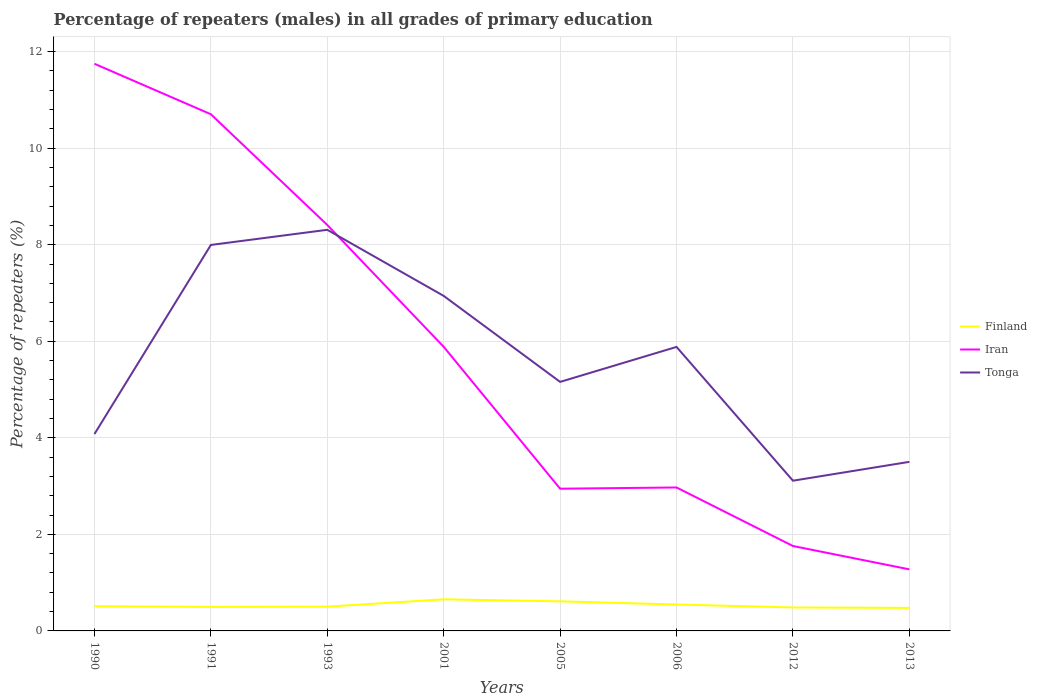Across all years, what is the maximum percentage of repeaters (males) in Finland?
Ensure brevity in your answer.  0.48. What is the total percentage of repeaters (males) in Iran in the graph?
Give a very brief answer. 4.82. What is the difference between the highest and the second highest percentage of repeaters (males) in Tonga?
Offer a terse response. 5.2. What is the difference between the highest and the lowest percentage of repeaters (males) in Iran?
Your response must be concise. 4. Is the percentage of repeaters (males) in Tonga strictly greater than the percentage of repeaters (males) in Finland over the years?
Keep it short and to the point. No. How many legend labels are there?
Provide a short and direct response. 3. What is the title of the graph?
Ensure brevity in your answer.  Percentage of repeaters (males) in all grades of primary education. Does "Middle income" appear as one of the legend labels in the graph?
Make the answer very short. No. What is the label or title of the X-axis?
Your answer should be compact. Years. What is the label or title of the Y-axis?
Your answer should be compact. Percentage of repeaters (%). What is the Percentage of repeaters (%) of Finland in 1990?
Your response must be concise. 0.51. What is the Percentage of repeaters (%) of Iran in 1990?
Provide a short and direct response. 11.75. What is the Percentage of repeaters (%) of Tonga in 1990?
Your answer should be very brief. 4.08. What is the Percentage of repeaters (%) in Finland in 1991?
Ensure brevity in your answer.  0.5. What is the Percentage of repeaters (%) in Iran in 1991?
Ensure brevity in your answer.  10.7. What is the Percentage of repeaters (%) in Tonga in 1991?
Your answer should be very brief. 7.99. What is the Percentage of repeaters (%) in Finland in 1993?
Your answer should be very brief. 0.5. What is the Percentage of repeaters (%) of Iran in 1993?
Keep it short and to the point. 8.41. What is the Percentage of repeaters (%) in Tonga in 1993?
Offer a terse response. 8.31. What is the Percentage of repeaters (%) in Finland in 2001?
Make the answer very short. 0.65. What is the Percentage of repeaters (%) of Iran in 2001?
Your response must be concise. 5.88. What is the Percentage of repeaters (%) of Tonga in 2001?
Your answer should be compact. 6.94. What is the Percentage of repeaters (%) of Finland in 2005?
Your answer should be very brief. 0.61. What is the Percentage of repeaters (%) of Iran in 2005?
Your answer should be very brief. 2.95. What is the Percentage of repeaters (%) in Tonga in 2005?
Ensure brevity in your answer.  5.16. What is the Percentage of repeaters (%) in Finland in 2006?
Keep it short and to the point. 0.55. What is the Percentage of repeaters (%) in Iran in 2006?
Ensure brevity in your answer.  2.97. What is the Percentage of repeaters (%) of Tonga in 2006?
Make the answer very short. 5.88. What is the Percentage of repeaters (%) of Finland in 2012?
Offer a terse response. 0.49. What is the Percentage of repeaters (%) of Iran in 2012?
Give a very brief answer. 1.76. What is the Percentage of repeaters (%) of Tonga in 2012?
Offer a very short reply. 3.11. What is the Percentage of repeaters (%) of Finland in 2013?
Provide a short and direct response. 0.48. What is the Percentage of repeaters (%) of Iran in 2013?
Your answer should be very brief. 1.28. What is the Percentage of repeaters (%) in Tonga in 2013?
Make the answer very short. 3.5. Across all years, what is the maximum Percentage of repeaters (%) of Finland?
Your answer should be compact. 0.65. Across all years, what is the maximum Percentage of repeaters (%) in Iran?
Offer a terse response. 11.75. Across all years, what is the maximum Percentage of repeaters (%) of Tonga?
Offer a very short reply. 8.31. Across all years, what is the minimum Percentage of repeaters (%) of Finland?
Make the answer very short. 0.48. Across all years, what is the minimum Percentage of repeaters (%) in Iran?
Your answer should be compact. 1.28. Across all years, what is the minimum Percentage of repeaters (%) of Tonga?
Your answer should be very brief. 3.11. What is the total Percentage of repeaters (%) of Finland in the graph?
Your answer should be compact. 4.29. What is the total Percentage of repeaters (%) in Iran in the graph?
Keep it short and to the point. 45.69. What is the total Percentage of repeaters (%) in Tonga in the graph?
Offer a very short reply. 44.98. What is the difference between the Percentage of repeaters (%) of Finland in 1990 and that in 1991?
Your answer should be very brief. 0.01. What is the difference between the Percentage of repeaters (%) in Iran in 1990 and that in 1991?
Your response must be concise. 1.05. What is the difference between the Percentage of repeaters (%) of Tonga in 1990 and that in 1991?
Give a very brief answer. -3.92. What is the difference between the Percentage of repeaters (%) in Finland in 1990 and that in 1993?
Make the answer very short. 0.01. What is the difference between the Percentage of repeaters (%) of Iran in 1990 and that in 1993?
Give a very brief answer. 3.34. What is the difference between the Percentage of repeaters (%) in Tonga in 1990 and that in 1993?
Your response must be concise. -4.23. What is the difference between the Percentage of repeaters (%) in Finland in 1990 and that in 2001?
Give a very brief answer. -0.14. What is the difference between the Percentage of repeaters (%) in Iran in 1990 and that in 2001?
Give a very brief answer. 5.86. What is the difference between the Percentage of repeaters (%) of Tonga in 1990 and that in 2001?
Provide a succinct answer. -2.86. What is the difference between the Percentage of repeaters (%) of Finland in 1990 and that in 2005?
Offer a very short reply. -0.1. What is the difference between the Percentage of repeaters (%) in Iran in 1990 and that in 2005?
Your answer should be very brief. 8.8. What is the difference between the Percentage of repeaters (%) of Tonga in 1990 and that in 2005?
Your answer should be very brief. -1.08. What is the difference between the Percentage of repeaters (%) of Finland in 1990 and that in 2006?
Your response must be concise. -0.04. What is the difference between the Percentage of repeaters (%) of Iran in 1990 and that in 2006?
Provide a short and direct response. 8.78. What is the difference between the Percentage of repeaters (%) in Tonga in 1990 and that in 2006?
Make the answer very short. -1.8. What is the difference between the Percentage of repeaters (%) in Finland in 1990 and that in 2012?
Keep it short and to the point. 0.03. What is the difference between the Percentage of repeaters (%) in Iran in 1990 and that in 2012?
Offer a very short reply. 9.99. What is the difference between the Percentage of repeaters (%) in Tonga in 1990 and that in 2012?
Offer a terse response. 0.97. What is the difference between the Percentage of repeaters (%) of Finland in 1990 and that in 2013?
Provide a succinct answer. 0.03. What is the difference between the Percentage of repeaters (%) in Iran in 1990 and that in 2013?
Offer a terse response. 10.47. What is the difference between the Percentage of repeaters (%) of Tonga in 1990 and that in 2013?
Give a very brief answer. 0.58. What is the difference between the Percentage of repeaters (%) of Finland in 1991 and that in 1993?
Your answer should be very brief. -0.01. What is the difference between the Percentage of repeaters (%) of Iran in 1991 and that in 1993?
Your response must be concise. 2.29. What is the difference between the Percentage of repeaters (%) in Tonga in 1991 and that in 1993?
Your answer should be compact. -0.31. What is the difference between the Percentage of repeaters (%) of Finland in 1991 and that in 2001?
Make the answer very short. -0.16. What is the difference between the Percentage of repeaters (%) in Iran in 1991 and that in 2001?
Provide a short and direct response. 4.82. What is the difference between the Percentage of repeaters (%) in Tonga in 1991 and that in 2001?
Offer a terse response. 1.06. What is the difference between the Percentage of repeaters (%) in Finland in 1991 and that in 2005?
Provide a succinct answer. -0.12. What is the difference between the Percentage of repeaters (%) in Iran in 1991 and that in 2005?
Give a very brief answer. 7.76. What is the difference between the Percentage of repeaters (%) in Tonga in 1991 and that in 2005?
Your answer should be very brief. 2.84. What is the difference between the Percentage of repeaters (%) in Finland in 1991 and that in 2006?
Make the answer very short. -0.05. What is the difference between the Percentage of repeaters (%) in Iran in 1991 and that in 2006?
Ensure brevity in your answer.  7.73. What is the difference between the Percentage of repeaters (%) of Tonga in 1991 and that in 2006?
Keep it short and to the point. 2.11. What is the difference between the Percentage of repeaters (%) of Finland in 1991 and that in 2012?
Your answer should be compact. 0.01. What is the difference between the Percentage of repeaters (%) of Iran in 1991 and that in 2012?
Your answer should be compact. 8.94. What is the difference between the Percentage of repeaters (%) in Tonga in 1991 and that in 2012?
Make the answer very short. 4.88. What is the difference between the Percentage of repeaters (%) of Finland in 1991 and that in 2013?
Provide a short and direct response. 0.02. What is the difference between the Percentage of repeaters (%) in Iran in 1991 and that in 2013?
Give a very brief answer. 9.43. What is the difference between the Percentage of repeaters (%) in Tonga in 1991 and that in 2013?
Make the answer very short. 4.49. What is the difference between the Percentage of repeaters (%) in Finland in 1993 and that in 2001?
Your answer should be very brief. -0.15. What is the difference between the Percentage of repeaters (%) of Iran in 1993 and that in 2001?
Make the answer very short. 2.52. What is the difference between the Percentage of repeaters (%) in Tonga in 1993 and that in 2001?
Offer a very short reply. 1.37. What is the difference between the Percentage of repeaters (%) of Finland in 1993 and that in 2005?
Provide a succinct answer. -0.11. What is the difference between the Percentage of repeaters (%) in Iran in 1993 and that in 2005?
Your answer should be compact. 5.46. What is the difference between the Percentage of repeaters (%) of Tonga in 1993 and that in 2005?
Your answer should be compact. 3.15. What is the difference between the Percentage of repeaters (%) of Finland in 1993 and that in 2006?
Give a very brief answer. -0.04. What is the difference between the Percentage of repeaters (%) in Iran in 1993 and that in 2006?
Keep it short and to the point. 5.44. What is the difference between the Percentage of repeaters (%) in Tonga in 1993 and that in 2006?
Keep it short and to the point. 2.43. What is the difference between the Percentage of repeaters (%) of Finland in 1993 and that in 2012?
Your response must be concise. 0.02. What is the difference between the Percentage of repeaters (%) of Iran in 1993 and that in 2012?
Offer a terse response. 6.65. What is the difference between the Percentage of repeaters (%) of Tonga in 1993 and that in 2012?
Ensure brevity in your answer.  5.2. What is the difference between the Percentage of repeaters (%) of Finland in 1993 and that in 2013?
Your answer should be compact. 0.03. What is the difference between the Percentage of repeaters (%) in Iran in 1993 and that in 2013?
Make the answer very short. 7.13. What is the difference between the Percentage of repeaters (%) of Tonga in 1993 and that in 2013?
Offer a terse response. 4.81. What is the difference between the Percentage of repeaters (%) in Finland in 2001 and that in 2005?
Make the answer very short. 0.04. What is the difference between the Percentage of repeaters (%) of Iran in 2001 and that in 2005?
Give a very brief answer. 2.94. What is the difference between the Percentage of repeaters (%) of Tonga in 2001 and that in 2005?
Your answer should be compact. 1.78. What is the difference between the Percentage of repeaters (%) of Finland in 2001 and that in 2006?
Make the answer very short. 0.11. What is the difference between the Percentage of repeaters (%) of Iran in 2001 and that in 2006?
Offer a very short reply. 2.91. What is the difference between the Percentage of repeaters (%) of Tonga in 2001 and that in 2006?
Your response must be concise. 1.06. What is the difference between the Percentage of repeaters (%) in Finland in 2001 and that in 2012?
Offer a terse response. 0.17. What is the difference between the Percentage of repeaters (%) in Iran in 2001 and that in 2012?
Keep it short and to the point. 4.13. What is the difference between the Percentage of repeaters (%) in Tonga in 2001 and that in 2012?
Ensure brevity in your answer.  3.83. What is the difference between the Percentage of repeaters (%) in Finland in 2001 and that in 2013?
Your answer should be compact. 0.18. What is the difference between the Percentage of repeaters (%) in Iran in 2001 and that in 2013?
Your answer should be very brief. 4.61. What is the difference between the Percentage of repeaters (%) in Tonga in 2001 and that in 2013?
Make the answer very short. 3.44. What is the difference between the Percentage of repeaters (%) of Finland in 2005 and that in 2006?
Provide a succinct answer. 0.07. What is the difference between the Percentage of repeaters (%) in Iran in 2005 and that in 2006?
Provide a succinct answer. -0.03. What is the difference between the Percentage of repeaters (%) in Tonga in 2005 and that in 2006?
Keep it short and to the point. -0.72. What is the difference between the Percentage of repeaters (%) in Finland in 2005 and that in 2012?
Make the answer very short. 0.13. What is the difference between the Percentage of repeaters (%) of Iran in 2005 and that in 2012?
Ensure brevity in your answer.  1.19. What is the difference between the Percentage of repeaters (%) in Tonga in 2005 and that in 2012?
Your answer should be very brief. 2.05. What is the difference between the Percentage of repeaters (%) in Finland in 2005 and that in 2013?
Your response must be concise. 0.14. What is the difference between the Percentage of repeaters (%) of Iran in 2005 and that in 2013?
Your answer should be compact. 1.67. What is the difference between the Percentage of repeaters (%) of Tonga in 2005 and that in 2013?
Provide a succinct answer. 1.66. What is the difference between the Percentage of repeaters (%) in Finland in 2006 and that in 2012?
Provide a short and direct response. 0.06. What is the difference between the Percentage of repeaters (%) in Iran in 2006 and that in 2012?
Keep it short and to the point. 1.21. What is the difference between the Percentage of repeaters (%) in Tonga in 2006 and that in 2012?
Offer a terse response. 2.77. What is the difference between the Percentage of repeaters (%) of Finland in 2006 and that in 2013?
Offer a very short reply. 0.07. What is the difference between the Percentage of repeaters (%) in Iran in 2006 and that in 2013?
Offer a very short reply. 1.7. What is the difference between the Percentage of repeaters (%) in Tonga in 2006 and that in 2013?
Keep it short and to the point. 2.38. What is the difference between the Percentage of repeaters (%) of Finland in 2012 and that in 2013?
Offer a terse response. 0.01. What is the difference between the Percentage of repeaters (%) of Iran in 2012 and that in 2013?
Give a very brief answer. 0.48. What is the difference between the Percentage of repeaters (%) of Tonga in 2012 and that in 2013?
Your answer should be very brief. -0.39. What is the difference between the Percentage of repeaters (%) in Finland in 1990 and the Percentage of repeaters (%) in Iran in 1991?
Offer a very short reply. -10.19. What is the difference between the Percentage of repeaters (%) in Finland in 1990 and the Percentage of repeaters (%) in Tonga in 1991?
Make the answer very short. -7.48. What is the difference between the Percentage of repeaters (%) in Iran in 1990 and the Percentage of repeaters (%) in Tonga in 1991?
Make the answer very short. 3.75. What is the difference between the Percentage of repeaters (%) of Finland in 1990 and the Percentage of repeaters (%) of Iran in 1993?
Offer a terse response. -7.9. What is the difference between the Percentage of repeaters (%) of Finland in 1990 and the Percentage of repeaters (%) of Tonga in 1993?
Offer a very short reply. -7.8. What is the difference between the Percentage of repeaters (%) of Iran in 1990 and the Percentage of repeaters (%) of Tonga in 1993?
Provide a succinct answer. 3.44. What is the difference between the Percentage of repeaters (%) in Finland in 1990 and the Percentage of repeaters (%) in Iran in 2001?
Offer a very short reply. -5.37. What is the difference between the Percentage of repeaters (%) of Finland in 1990 and the Percentage of repeaters (%) of Tonga in 2001?
Provide a short and direct response. -6.43. What is the difference between the Percentage of repeaters (%) in Iran in 1990 and the Percentage of repeaters (%) in Tonga in 2001?
Offer a terse response. 4.81. What is the difference between the Percentage of repeaters (%) of Finland in 1990 and the Percentage of repeaters (%) of Iran in 2005?
Offer a very short reply. -2.43. What is the difference between the Percentage of repeaters (%) of Finland in 1990 and the Percentage of repeaters (%) of Tonga in 2005?
Ensure brevity in your answer.  -4.65. What is the difference between the Percentage of repeaters (%) of Iran in 1990 and the Percentage of repeaters (%) of Tonga in 2005?
Offer a very short reply. 6.59. What is the difference between the Percentage of repeaters (%) of Finland in 1990 and the Percentage of repeaters (%) of Iran in 2006?
Your answer should be very brief. -2.46. What is the difference between the Percentage of repeaters (%) in Finland in 1990 and the Percentage of repeaters (%) in Tonga in 2006?
Your response must be concise. -5.37. What is the difference between the Percentage of repeaters (%) of Iran in 1990 and the Percentage of repeaters (%) of Tonga in 2006?
Your answer should be compact. 5.86. What is the difference between the Percentage of repeaters (%) of Finland in 1990 and the Percentage of repeaters (%) of Iran in 2012?
Provide a succinct answer. -1.25. What is the difference between the Percentage of repeaters (%) of Finland in 1990 and the Percentage of repeaters (%) of Tonga in 2012?
Make the answer very short. -2.6. What is the difference between the Percentage of repeaters (%) in Iran in 1990 and the Percentage of repeaters (%) in Tonga in 2012?
Your answer should be compact. 8.64. What is the difference between the Percentage of repeaters (%) of Finland in 1990 and the Percentage of repeaters (%) of Iran in 2013?
Keep it short and to the point. -0.76. What is the difference between the Percentage of repeaters (%) in Finland in 1990 and the Percentage of repeaters (%) in Tonga in 2013?
Give a very brief answer. -2.99. What is the difference between the Percentage of repeaters (%) of Iran in 1990 and the Percentage of repeaters (%) of Tonga in 2013?
Provide a succinct answer. 8.25. What is the difference between the Percentage of repeaters (%) of Finland in 1991 and the Percentage of repeaters (%) of Iran in 1993?
Your answer should be very brief. -7.91. What is the difference between the Percentage of repeaters (%) of Finland in 1991 and the Percentage of repeaters (%) of Tonga in 1993?
Provide a succinct answer. -7.81. What is the difference between the Percentage of repeaters (%) of Iran in 1991 and the Percentage of repeaters (%) of Tonga in 1993?
Give a very brief answer. 2.39. What is the difference between the Percentage of repeaters (%) of Finland in 1991 and the Percentage of repeaters (%) of Iran in 2001?
Offer a terse response. -5.39. What is the difference between the Percentage of repeaters (%) of Finland in 1991 and the Percentage of repeaters (%) of Tonga in 2001?
Provide a succinct answer. -6.44. What is the difference between the Percentage of repeaters (%) in Iran in 1991 and the Percentage of repeaters (%) in Tonga in 2001?
Offer a very short reply. 3.76. What is the difference between the Percentage of repeaters (%) of Finland in 1991 and the Percentage of repeaters (%) of Iran in 2005?
Your answer should be compact. -2.45. What is the difference between the Percentage of repeaters (%) of Finland in 1991 and the Percentage of repeaters (%) of Tonga in 2005?
Provide a short and direct response. -4.66. What is the difference between the Percentage of repeaters (%) of Iran in 1991 and the Percentage of repeaters (%) of Tonga in 2005?
Give a very brief answer. 5.54. What is the difference between the Percentage of repeaters (%) in Finland in 1991 and the Percentage of repeaters (%) in Iran in 2006?
Your answer should be compact. -2.47. What is the difference between the Percentage of repeaters (%) of Finland in 1991 and the Percentage of repeaters (%) of Tonga in 2006?
Keep it short and to the point. -5.39. What is the difference between the Percentage of repeaters (%) in Iran in 1991 and the Percentage of repeaters (%) in Tonga in 2006?
Provide a succinct answer. 4.82. What is the difference between the Percentage of repeaters (%) in Finland in 1991 and the Percentage of repeaters (%) in Iran in 2012?
Your answer should be compact. -1.26. What is the difference between the Percentage of repeaters (%) of Finland in 1991 and the Percentage of repeaters (%) of Tonga in 2012?
Make the answer very short. -2.61. What is the difference between the Percentage of repeaters (%) in Iran in 1991 and the Percentage of repeaters (%) in Tonga in 2012?
Provide a short and direct response. 7.59. What is the difference between the Percentage of repeaters (%) in Finland in 1991 and the Percentage of repeaters (%) in Iran in 2013?
Ensure brevity in your answer.  -0.78. What is the difference between the Percentage of repeaters (%) in Finland in 1991 and the Percentage of repeaters (%) in Tonga in 2013?
Your answer should be very brief. -3. What is the difference between the Percentage of repeaters (%) in Iran in 1991 and the Percentage of repeaters (%) in Tonga in 2013?
Your response must be concise. 7.2. What is the difference between the Percentage of repeaters (%) of Finland in 1993 and the Percentage of repeaters (%) of Iran in 2001?
Make the answer very short. -5.38. What is the difference between the Percentage of repeaters (%) of Finland in 1993 and the Percentage of repeaters (%) of Tonga in 2001?
Your answer should be compact. -6.44. What is the difference between the Percentage of repeaters (%) in Iran in 1993 and the Percentage of repeaters (%) in Tonga in 2001?
Your response must be concise. 1.47. What is the difference between the Percentage of repeaters (%) in Finland in 1993 and the Percentage of repeaters (%) in Iran in 2005?
Your response must be concise. -2.44. What is the difference between the Percentage of repeaters (%) of Finland in 1993 and the Percentage of repeaters (%) of Tonga in 2005?
Offer a very short reply. -4.66. What is the difference between the Percentage of repeaters (%) of Iran in 1993 and the Percentage of repeaters (%) of Tonga in 2005?
Offer a very short reply. 3.25. What is the difference between the Percentage of repeaters (%) in Finland in 1993 and the Percentage of repeaters (%) in Iran in 2006?
Your answer should be compact. -2.47. What is the difference between the Percentage of repeaters (%) of Finland in 1993 and the Percentage of repeaters (%) of Tonga in 2006?
Your answer should be compact. -5.38. What is the difference between the Percentage of repeaters (%) of Iran in 1993 and the Percentage of repeaters (%) of Tonga in 2006?
Keep it short and to the point. 2.53. What is the difference between the Percentage of repeaters (%) of Finland in 1993 and the Percentage of repeaters (%) of Iran in 2012?
Make the answer very short. -1.26. What is the difference between the Percentage of repeaters (%) in Finland in 1993 and the Percentage of repeaters (%) in Tonga in 2012?
Your answer should be very brief. -2.61. What is the difference between the Percentage of repeaters (%) in Iran in 1993 and the Percentage of repeaters (%) in Tonga in 2012?
Give a very brief answer. 5.3. What is the difference between the Percentage of repeaters (%) of Finland in 1993 and the Percentage of repeaters (%) of Iran in 2013?
Ensure brevity in your answer.  -0.77. What is the difference between the Percentage of repeaters (%) of Finland in 1993 and the Percentage of repeaters (%) of Tonga in 2013?
Your answer should be very brief. -3. What is the difference between the Percentage of repeaters (%) of Iran in 1993 and the Percentage of repeaters (%) of Tonga in 2013?
Make the answer very short. 4.91. What is the difference between the Percentage of repeaters (%) of Finland in 2001 and the Percentage of repeaters (%) of Iran in 2005?
Make the answer very short. -2.29. What is the difference between the Percentage of repeaters (%) of Finland in 2001 and the Percentage of repeaters (%) of Tonga in 2005?
Offer a very short reply. -4.5. What is the difference between the Percentage of repeaters (%) in Iran in 2001 and the Percentage of repeaters (%) in Tonga in 2005?
Keep it short and to the point. 0.73. What is the difference between the Percentage of repeaters (%) in Finland in 2001 and the Percentage of repeaters (%) in Iran in 2006?
Give a very brief answer. -2.32. What is the difference between the Percentage of repeaters (%) of Finland in 2001 and the Percentage of repeaters (%) of Tonga in 2006?
Your answer should be very brief. -5.23. What is the difference between the Percentage of repeaters (%) of Iran in 2001 and the Percentage of repeaters (%) of Tonga in 2006?
Your response must be concise. 0. What is the difference between the Percentage of repeaters (%) of Finland in 2001 and the Percentage of repeaters (%) of Iran in 2012?
Your answer should be compact. -1.1. What is the difference between the Percentage of repeaters (%) in Finland in 2001 and the Percentage of repeaters (%) in Tonga in 2012?
Make the answer very short. -2.46. What is the difference between the Percentage of repeaters (%) in Iran in 2001 and the Percentage of repeaters (%) in Tonga in 2012?
Provide a short and direct response. 2.77. What is the difference between the Percentage of repeaters (%) in Finland in 2001 and the Percentage of repeaters (%) in Iran in 2013?
Ensure brevity in your answer.  -0.62. What is the difference between the Percentage of repeaters (%) in Finland in 2001 and the Percentage of repeaters (%) in Tonga in 2013?
Offer a very short reply. -2.85. What is the difference between the Percentage of repeaters (%) of Iran in 2001 and the Percentage of repeaters (%) of Tonga in 2013?
Your response must be concise. 2.38. What is the difference between the Percentage of repeaters (%) in Finland in 2005 and the Percentage of repeaters (%) in Iran in 2006?
Ensure brevity in your answer.  -2.36. What is the difference between the Percentage of repeaters (%) in Finland in 2005 and the Percentage of repeaters (%) in Tonga in 2006?
Make the answer very short. -5.27. What is the difference between the Percentage of repeaters (%) in Iran in 2005 and the Percentage of repeaters (%) in Tonga in 2006?
Provide a short and direct response. -2.94. What is the difference between the Percentage of repeaters (%) in Finland in 2005 and the Percentage of repeaters (%) in Iran in 2012?
Provide a short and direct response. -1.15. What is the difference between the Percentage of repeaters (%) in Finland in 2005 and the Percentage of repeaters (%) in Tonga in 2012?
Offer a terse response. -2.5. What is the difference between the Percentage of repeaters (%) in Iran in 2005 and the Percentage of repeaters (%) in Tonga in 2012?
Keep it short and to the point. -0.17. What is the difference between the Percentage of repeaters (%) in Finland in 2005 and the Percentage of repeaters (%) in Iran in 2013?
Keep it short and to the point. -0.66. What is the difference between the Percentage of repeaters (%) of Finland in 2005 and the Percentage of repeaters (%) of Tonga in 2013?
Offer a terse response. -2.89. What is the difference between the Percentage of repeaters (%) in Iran in 2005 and the Percentage of repeaters (%) in Tonga in 2013?
Offer a terse response. -0.56. What is the difference between the Percentage of repeaters (%) in Finland in 2006 and the Percentage of repeaters (%) in Iran in 2012?
Give a very brief answer. -1.21. What is the difference between the Percentage of repeaters (%) in Finland in 2006 and the Percentage of repeaters (%) in Tonga in 2012?
Your answer should be compact. -2.56. What is the difference between the Percentage of repeaters (%) in Iran in 2006 and the Percentage of repeaters (%) in Tonga in 2012?
Offer a terse response. -0.14. What is the difference between the Percentage of repeaters (%) in Finland in 2006 and the Percentage of repeaters (%) in Iran in 2013?
Give a very brief answer. -0.73. What is the difference between the Percentage of repeaters (%) of Finland in 2006 and the Percentage of repeaters (%) of Tonga in 2013?
Offer a very short reply. -2.96. What is the difference between the Percentage of repeaters (%) in Iran in 2006 and the Percentage of repeaters (%) in Tonga in 2013?
Give a very brief answer. -0.53. What is the difference between the Percentage of repeaters (%) in Finland in 2012 and the Percentage of repeaters (%) in Iran in 2013?
Your response must be concise. -0.79. What is the difference between the Percentage of repeaters (%) in Finland in 2012 and the Percentage of repeaters (%) in Tonga in 2013?
Your response must be concise. -3.02. What is the difference between the Percentage of repeaters (%) in Iran in 2012 and the Percentage of repeaters (%) in Tonga in 2013?
Your response must be concise. -1.74. What is the average Percentage of repeaters (%) in Finland per year?
Ensure brevity in your answer.  0.54. What is the average Percentage of repeaters (%) in Iran per year?
Your response must be concise. 5.71. What is the average Percentage of repeaters (%) of Tonga per year?
Ensure brevity in your answer.  5.62. In the year 1990, what is the difference between the Percentage of repeaters (%) of Finland and Percentage of repeaters (%) of Iran?
Provide a succinct answer. -11.24. In the year 1990, what is the difference between the Percentage of repeaters (%) in Finland and Percentage of repeaters (%) in Tonga?
Make the answer very short. -3.57. In the year 1990, what is the difference between the Percentage of repeaters (%) of Iran and Percentage of repeaters (%) of Tonga?
Your response must be concise. 7.67. In the year 1991, what is the difference between the Percentage of repeaters (%) of Finland and Percentage of repeaters (%) of Iran?
Your answer should be compact. -10.2. In the year 1991, what is the difference between the Percentage of repeaters (%) in Finland and Percentage of repeaters (%) in Tonga?
Keep it short and to the point. -7.5. In the year 1991, what is the difference between the Percentage of repeaters (%) in Iran and Percentage of repeaters (%) in Tonga?
Provide a succinct answer. 2.71. In the year 1993, what is the difference between the Percentage of repeaters (%) in Finland and Percentage of repeaters (%) in Iran?
Keep it short and to the point. -7.91. In the year 1993, what is the difference between the Percentage of repeaters (%) in Finland and Percentage of repeaters (%) in Tonga?
Your answer should be very brief. -7.81. In the year 1993, what is the difference between the Percentage of repeaters (%) of Iran and Percentage of repeaters (%) of Tonga?
Give a very brief answer. 0.1. In the year 2001, what is the difference between the Percentage of repeaters (%) of Finland and Percentage of repeaters (%) of Iran?
Give a very brief answer. -5.23. In the year 2001, what is the difference between the Percentage of repeaters (%) in Finland and Percentage of repeaters (%) in Tonga?
Provide a succinct answer. -6.29. In the year 2001, what is the difference between the Percentage of repeaters (%) of Iran and Percentage of repeaters (%) of Tonga?
Ensure brevity in your answer.  -1.05. In the year 2005, what is the difference between the Percentage of repeaters (%) in Finland and Percentage of repeaters (%) in Iran?
Ensure brevity in your answer.  -2.33. In the year 2005, what is the difference between the Percentage of repeaters (%) of Finland and Percentage of repeaters (%) of Tonga?
Make the answer very short. -4.55. In the year 2005, what is the difference between the Percentage of repeaters (%) in Iran and Percentage of repeaters (%) in Tonga?
Give a very brief answer. -2.21. In the year 2006, what is the difference between the Percentage of repeaters (%) of Finland and Percentage of repeaters (%) of Iran?
Keep it short and to the point. -2.42. In the year 2006, what is the difference between the Percentage of repeaters (%) in Finland and Percentage of repeaters (%) in Tonga?
Your answer should be compact. -5.34. In the year 2006, what is the difference between the Percentage of repeaters (%) of Iran and Percentage of repeaters (%) of Tonga?
Provide a short and direct response. -2.91. In the year 2012, what is the difference between the Percentage of repeaters (%) in Finland and Percentage of repeaters (%) in Iran?
Keep it short and to the point. -1.27. In the year 2012, what is the difference between the Percentage of repeaters (%) of Finland and Percentage of repeaters (%) of Tonga?
Make the answer very short. -2.63. In the year 2012, what is the difference between the Percentage of repeaters (%) of Iran and Percentage of repeaters (%) of Tonga?
Keep it short and to the point. -1.35. In the year 2013, what is the difference between the Percentage of repeaters (%) of Finland and Percentage of repeaters (%) of Iran?
Your response must be concise. -0.8. In the year 2013, what is the difference between the Percentage of repeaters (%) in Finland and Percentage of repeaters (%) in Tonga?
Your answer should be compact. -3.03. In the year 2013, what is the difference between the Percentage of repeaters (%) of Iran and Percentage of repeaters (%) of Tonga?
Offer a terse response. -2.23. What is the ratio of the Percentage of repeaters (%) of Finland in 1990 to that in 1991?
Keep it short and to the point. 1.03. What is the ratio of the Percentage of repeaters (%) in Iran in 1990 to that in 1991?
Ensure brevity in your answer.  1.1. What is the ratio of the Percentage of repeaters (%) in Tonga in 1990 to that in 1991?
Ensure brevity in your answer.  0.51. What is the ratio of the Percentage of repeaters (%) in Finland in 1990 to that in 1993?
Ensure brevity in your answer.  1.02. What is the ratio of the Percentage of repeaters (%) in Iran in 1990 to that in 1993?
Your answer should be very brief. 1.4. What is the ratio of the Percentage of repeaters (%) in Tonga in 1990 to that in 1993?
Offer a terse response. 0.49. What is the ratio of the Percentage of repeaters (%) of Finland in 1990 to that in 2001?
Your answer should be compact. 0.78. What is the ratio of the Percentage of repeaters (%) in Iran in 1990 to that in 2001?
Keep it short and to the point. 2. What is the ratio of the Percentage of repeaters (%) of Tonga in 1990 to that in 2001?
Make the answer very short. 0.59. What is the ratio of the Percentage of repeaters (%) in Finland in 1990 to that in 2005?
Offer a terse response. 0.83. What is the ratio of the Percentage of repeaters (%) of Iran in 1990 to that in 2005?
Your answer should be compact. 3.99. What is the ratio of the Percentage of repeaters (%) of Tonga in 1990 to that in 2005?
Offer a very short reply. 0.79. What is the ratio of the Percentage of repeaters (%) in Finland in 1990 to that in 2006?
Your response must be concise. 0.94. What is the ratio of the Percentage of repeaters (%) of Iran in 1990 to that in 2006?
Your response must be concise. 3.95. What is the ratio of the Percentage of repeaters (%) of Tonga in 1990 to that in 2006?
Provide a short and direct response. 0.69. What is the ratio of the Percentage of repeaters (%) in Finland in 1990 to that in 2012?
Provide a short and direct response. 1.05. What is the ratio of the Percentage of repeaters (%) of Iran in 1990 to that in 2012?
Give a very brief answer. 6.68. What is the ratio of the Percentage of repeaters (%) in Tonga in 1990 to that in 2012?
Offer a very short reply. 1.31. What is the ratio of the Percentage of repeaters (%) in Finland in 1990 to that in 2013?
Provide a succinct answer. 1.07. What is the ratio of the Percentage of repeaters (%) in Iran in 1990 to that in 2013?
Give a very brief answer. 9.21. What is the ratio of the Percentage of repeaters (%) in Tonga in 1990 to that in 2013?
Offer a very short reply. 1.16. What is the ratio of the Percentage of repeaters (%) in Finland in 1991 to that in 1993?
Keep it short and to the point. 0.99. What is the ratio of the Percentage of repeaters (%) of Iran in 1991 to that in 1993?
Give a very brief answer. 1.27. What is the ratio of the Percentage of repeaters (%) of Tonga in 1991 to that in 1993?
Provide a succinct answer. 0.96. What is the ratio of the Percentage of repeaters (%) in Finland in 1991 to that in 2001?
Make the answer very short. 0.76. What is the ratio of the Percentage of repeaters (%) in Iran in 1991 to that in 2001?
Provide a succinct answer. 1.82. What is the ratio of the Percentage of repeaters (%) of Tonga in 1991 to that in 2001?
Your answer should be compact. 1.15. What is the ratio of the Percentage of repeaters (%) in Finland in 1991 to that in 2005?
Provide a short and direct response. 0.81. What is the ratio of the Percentage of repeaters (%) of Iran in 1991 to that in 2005?
Your response must be concise. 3.63. What is the ratio of the Percentage of repeaters (%) of Tonga in 1991 to that in 2005?
Ensure brevity in your answer.  1.55. What is the ratio of the Percentage of repeaters (%) in Finland in 1991 to that in 2006?
Keep it short and to the point. 0.91. What is the ratio of the Percentage of repeaters (%) of Iran in 1991 to that in 2006?
Ensure brevity in your answer.  3.6. What is the ratio of the Percentage of repeaters (%) of Tonga in 1991 to that in 2006?
Ensure brevity in your answer.  1.36. What is the ratio of the Percentage of repeaters (%) in Finland in 1991 to that in 2012?
Your answer should be compact. 1.02. What is the ratio of the Percentage of repeaters (%) of Iran in 1991 to that in 2012?
Keep it short and to the point. 6.08. What is the ratio of the Percentage of repeaters (%) in Tonga in 1991 to that in 2012?
Provide a short and direct response. 2.57. What is the ratio of the Percentage of repeaters (%) of Finland in 1991 to that in 2013?
Offer a very short reply. 1.04. What is the ratio of the Percentage of repeaters (%) in Iran in 1991 to that in 2013?
Offer a very short reply. 8.39. What is the ratio of the Percentage of repeaters (%) of Tonga in 1991 to that in 2013?
Give a very brief answer. 2.28. What is the ratio of the Percentage of repeaters (%) in Finland in 1993 to that in 2001?
Offer a terse response. 0.77. What is the ratio of the Percentage of repeaters (%) in Iran in 1993 to that in 2001?
Offer a terse response. 1.43. What is the ratio of the Percentage of repeaters (%) in Tonga in 1993 to that in 2001?
Give a very brief answer. 1.2. What is the ratio of the Percentage of repeaters (%) of Finland in 1993 to that in 2005?
Your response must be concise. 0.82. What is the ratio of the Percentage of repeaters (%) in Iran in 1993 to that in 2005?
Your response must be concise. 2.85. What is the ratio of the Percentage of repeaters (%) of Tonga in 1993 to that in 2005?
Keep it short and to the point. 1.61. What is the ratio of the Percentage of repeaters (%) in Finland in 1993 to that in 2006?
Give a very brief answer. 0.92. What is the ratio of the Percentage of repeaters (%) of Iran in 1993 to that in 2006?
Your answer should be very brief. 2.83. What is the ratio of the Percentage of repeaters (%) in Tonga in 1993 to that in 2006?
Offer a terse response. 1.41. What is the ratio of the Percentage of repeaters (%) in Finland in 1993 to that in 2012?
Offer a terse response. 1.03. What is the ratio of the Percentage of repeaters (%) in Iran in 1993 to that in 2012?
Provide a succinct answer. 4.78. What is the ratio of the Percentage of repeaters (%) in Tonga in 1993 to that in 2012?
Provide a succinct answer. 2.67. What is the ratio of the Percentage of repeaters (%) of Finland in 1993 to that in 2013?
Make the answer very short. 1.05. What is the ratio of the Percentage of repeaters (%) of Iran in 1993 to that in 2013?
Your answer should be compact. 6.59. What is the ratio of the Percentage of repeaters (%) in Tonga in 1993 to that in 2013?
Provide a succinct answer. 2.37. What is the ratio of the Percentage of repeaters (%) of Finland in 2001 to that in 2005?
Keep it short and to the point. 1.07. What is the ratio of the Percentage of repeaters (%) of Iran in 2001 to that in 2005?
Ensure brevity in your answer.  2. What is the ratio of the Percentage of repeaters (%) of Tonga in 2001 to that in 2005?
Provide a succinct answer. 1.35. What is the ratio of the Percentage of repeaters (%) in Finland in 2001 to that in 2006?
Your response must be concise. 1.2. What is the ratio of the Percentage of repeaters (%) in Iran in 2001 to that in 2006?
Your response must be concise. 1.98. What is the ratio of the Percentage of repeaters (%) of Tonga in 2001 to that in 2006?
Your answer should be very brief. 1.18. What is the ratio of the Percentage of repeaters (%) in Finland in 2001 to that in 2012?
Ensure brevity in your answer.  1.35. What is the ratio of the Percentage of repeaters (%) of Iran in 2001 to that in 2012?
Provide a succinct answer. 3.35. What is the ratio of the Percentage of repeaters (%) in Tonga in 2001 to that in 2012?
Give a very brief answer. 2.23. What is the ratio of the Percentage of repeaters (%) in Finland in 2001 to that in 2013?
Your response must be concise. 1.37. What is the ratio of the Percentage of repeaters (%) in Iran in 2001 to that in 2013?
Your answer should be compact. 4.61. What is the ratio of the Percentage of repeaters (%) in Tonga in 2001 to that in 2013?
Provide a short and direct response. 1.98. What is the ratio of the Percentage of repeaters (%) in Finland in 2005 to that in 2006?
Your response must be concise. 1.12. What is the ratio of the Percentage of repeaters (%) in Iran in 2005 to that in 2006?
Offer a very short reply. 0.99. What is the ratio of the Percentage of repeaters (%) in Tonga in 2005 to that in 2006?
Keep it short and to the point. 0.88. What is the ratio of the Percentage of repeaters (%) of Finland in 2005 to that in 2012?
Your answer should be compact. 1.26. What is the ratio of the Percentage of repeaters (%) of Iran in 2005 to that in 2012?
Offer a terse response. 1.67. What is the ratio of the Percentage of repeaters (%) of Tonga in 2005 to that in 2012?
Ensure brevity in your answer.  1.66. What is the ratio of the Percentage of repeaters (%) of Finland in 2005 to that in 2013?
Ensure brevity in your answer.  1.28. What is the ratio of the Percentage of repeaters (%) of Iran in 2005 to that in 2013?
Offer a very short reply. 2.31. What is the ratio of the Percentage of repeaters (%) of Tonga in 2005 to that in 2013?
Give a very brief answer. 1.47. What is the ratio of the Percentage of repeaters (%) of Finland in 2006 to that in 2012?
Provide a short and direct response. 1.13. What is the ratio of the Percentage of repeaters (%) in Iran in 2006 to that in 2012?
Give a very brief answer. 1.69. What is the ratio of the Percentage of repeaters (%) of Tonga in 2006 to that in 2012?
Offer a very short reply. 1.89. What is the ratio of the Percentage of repeaters (%) in Finland in 2006 to that in 2013?
Provide a short and direct response. 1.15. What is the ratio of the Percentage of repeaters (%) of Iran in 2006 to that in 2013?
Your answer should be compact. 2.33. What is the ratio of the Percentage of repeaters (%) in Tonga in 2006 to that in 2013?
Your answer should be compact. 1.68. What is the ratio of the Percentage of repeaters (%) in Finland in 2012 to that in 2013?
Provide a succinct answer. 1.02. What is the ratio of the Percentage of repeaters (%) of Iran in 2012 to that in 2013?
Ensure brevity in your answer.  1.38. What is the ratio of the Percentage of repeaters (%) of Tonga in 2012 to that in 2013?
Make the answer very short. 0.89. What is the difference between the highest and the second highest Percentage of repeaters (%) in Finland?
Offer a very short reply. 0.04. What is the difference between the highest and the second highest Percentage of repeaters (%) of Iran?
Keep it short and to the point. 1.05. What is the difference between the highest and the second highest Percentage of repeaters (%) in Tonga?
Make the answer very short. 0.31. What is the difference between the highest and the lowest Percentage of repeaters (%) of Finland?
Make the answer very short. 0.18. What is the difference between the highest and the lowest Percentage of repeaters (%) in Iran?
Provide a short and direct response. 10.47. What is the difference between the highest and the lowest Percentage of repeaters (%) of Tonga?
Keep it short and to the point. 5.2. 